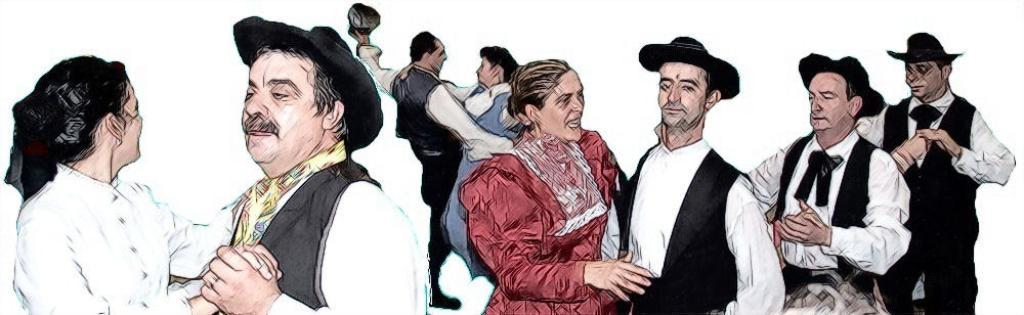What type of artwork is depicted in the image? The image is a painting. What is happening in the painting? There is a group of couples in the painting, and they are dancing together. Where can a cobweb be seen in the painting? There is no cobweb present in the painting; it is a depiction of dancing couples. 